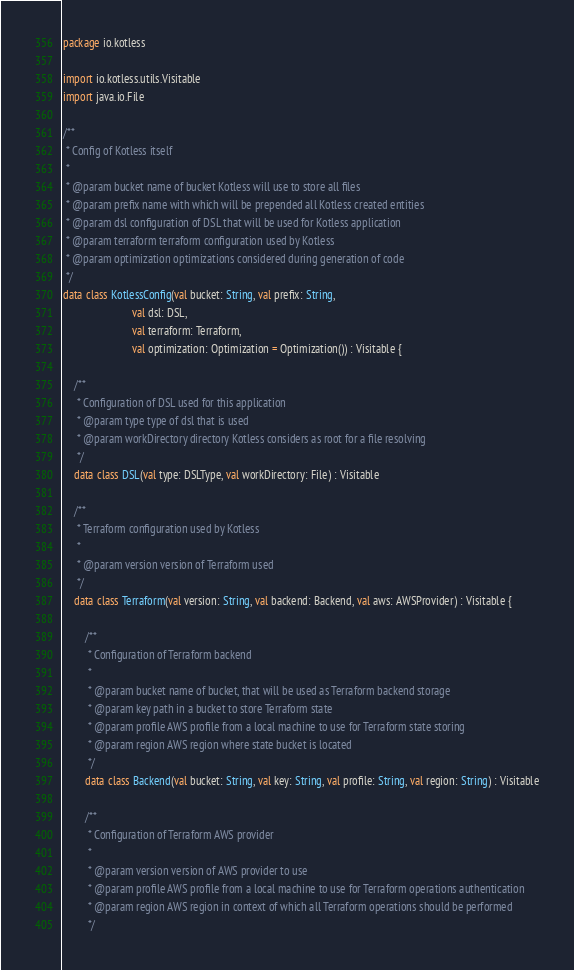<code> <loc_0><loc_0><loc_500><loc_500><_Kotlin_>package io.kotless

import io.kotless.utils.Visitable
import java.io.File

/**
 * Config of Kotless itself
 *
 * @param bucket name of bucket Kotless will use to store all files
 * @param prefix name with which will be prepended all Kotless created entities
 * @param dsl configuration of DSL that will be used for Kotless application
 * @param terraform terraform configuration used by Kotless
 * @param optimization optimizations considered during generation of code
 */
data class KotlessConfig(val bucket: String, val prefix: String,
                         val dsl: DSL,
                         val terraform: Terraform,
                         val optimization: Optimization = Optimization()) : Visitable {

    /**
     * Configuration of DSL used for this application
     * @param type type of dsl that is used
     * @param workDirectory directory Kotless considers as root for a file resolving
     */
    data class DSL(val type: DSLType, val workDirectory: File) : Visitable

    /**
     * Terraform configuration used by Kotless
     *
     * @param version version of Terraform used
     */
    data class Terraform(val version: String, val backend: Backend, val aws: AWSProvider) : Visitable {

        /**
         * Configuration of Terraform backend
         *
         * @param bucket name of bucket, that will be used as Terraform backend storage
         * @param key path in a bucket to store Terraform state
         * @param profile AWS profile from a local machine to use for Terraform state storing
         * @param region AWS region where state bucket is located
         */
        data class Backend(val bucket: String, val key: String, val profile: String, val region: String) : Visitable

        /**
         * Configuration of Terraform AWS provider
         *
         * @param version version of AWS provider to use
         * @param profile AWS profile from a local machine to use for Terraform operations authentication
         * @param region AWS region in context of which all Terraform operations should be performed
         */</code> 